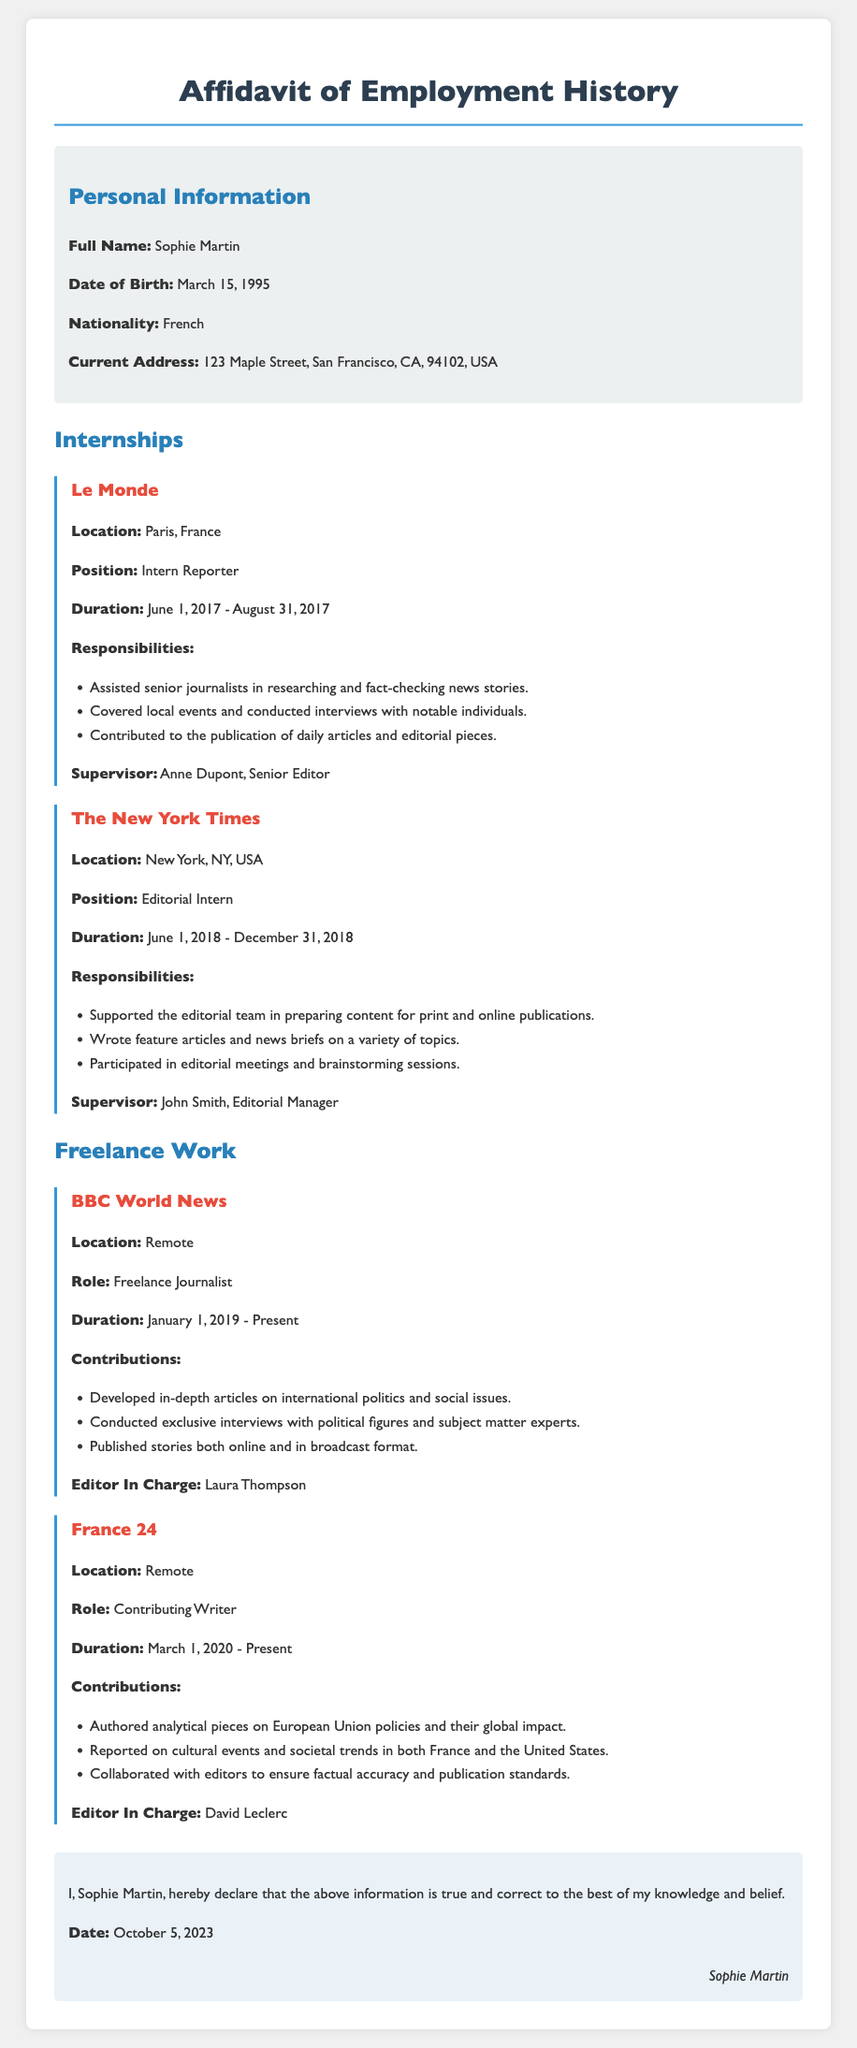What is the full name of the individual? The document states the full name of the individual as Sophie Martin.
Answer: Sophie Martin What is the position held at Le Monde? The document lists the position held at Le Monde as Intern Reporter.
Answer: Intern Reporter When did Sophie Martin work as an Editorial Intern at The New York Times? The duration of the internship at The New York Times is mentioned as June 1, 2018 - December 31, 2018.
Answer: June 1, 2018 - December 31, 2018 Who was the supervisor at BBC World News? The document identifies Laura Thompson as the Editor In Charge at BBC World News.
Answer: Laura Thompson What type of content does Sophie Martin contribute to France 24? The contributions mentioned in the document include analytical pieces on European Union policies and cultural event reports.
Answer: Analytical pieces and cultural reports What is the current role of Sophie Martin in her freelance work? The document describes her role at BBC World News as Freelance Journalist and at France 24 as Contributing Writer.
Answer: Freelance Journalist and Contributing Writer How long is the duration of the internship at Le Monde? The document mentions that the internship at Le Monde lasted from June 1, 2017 to August 31, 2017, which is 3 months.
Answer: 3 months What does Sophie Martin declare in the document? The declaration states that she believes the information provided is true and correct to her knowledge.
Answer: True and correct information What is the date of the affidavit? The document specifies the date of the affidavit as October 5, 2023.
Answer: October 5, 2023 